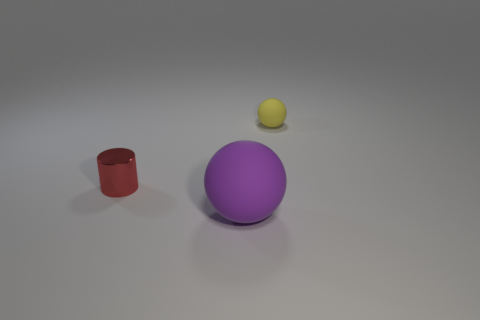Is there any other thing that has the same material as the tiny red thing?
Provide a short and direct response. No. What material is the red thing that is the same size as the yellow matte thing?
Make the answer very short. Metal. What size is the object that is behind the metallic cylinder?
Make the answer very short. Small. Is the size of the matte object that is in front of the yellow ball the same as the rubber object that is behind the tiny red thing?
Offer a very short reply. No. How many big balls are made of the same material as the small yellow object?
Keep it short and to the point. 1. What is the color of the small cylinder?
Provide a succinct answer. Red. Are there any spheres behind the shiny cylinder?
Offer a very short reply. Yes. What number of large rubber balls have the same color as the small cylinder?
Your answer should be compact. 0. There is a rubber object in front of the tiny thing to the left of the purple matte sphere; how big is it?
Your answer should be very brief. Large. What shape is the red object?
Your response must be concise. Cylinder. 